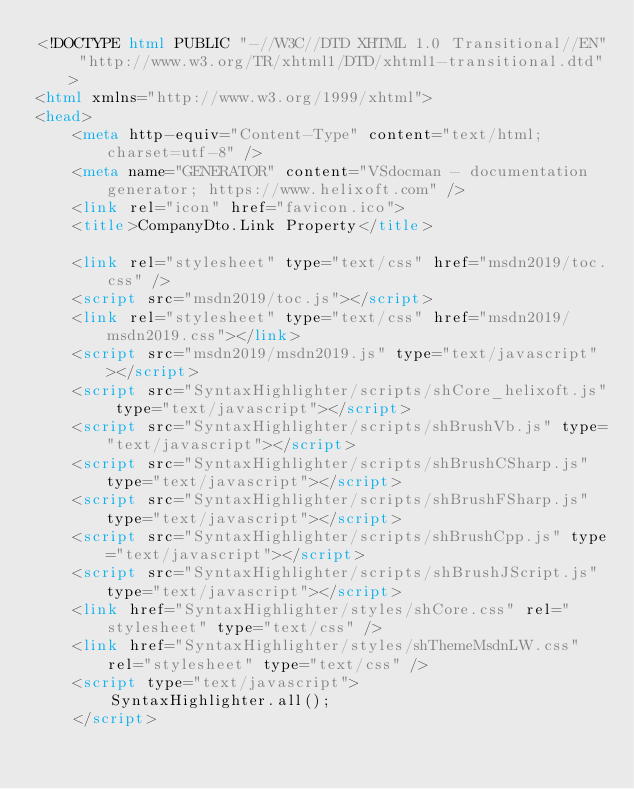<code> <loc_0><loc_0><loc_500><loc_500><_HTML_><!DOCTYPE html PUBLIC "-//W3C//DTD XHTML 1.0 Transitional//EN" "http://www.w3.org/TR/xhtml1/DTD/xhtml1-transitional.dtd">
<html xmlns="http://www.w3.org/1999/xhtml">
<head>
	<meta http-equiv="Content-Type" content="text/html; charset=utf-8" />
	<meta name="GENERATOR" content="VSdocman - documentation generator; https://www.helixoft.com" />
	<link rel="icon" href="favicon.ico">
	<title>CompanyDto.Link Property</title>

	<link rel="stylesheet" type="text/css" href="msdn2019/toc.css" />
	<script src="msdn2019/toc.js"></script>
	<link rel="stylesheet" type="text/css" href="msdn2019/msdn2019.css"></link>
	<script src="msdn2019/msdn2019.js" type="text/javascript"></script>
	<script src="SyntaxHighlighter/scripts/shCore_helixoft.js" type="text/javascript"></script>
	<script src="SyntaxHighlighter/scripts/shBrushVb.js" type="text/javascript"></script>
	<script src="SyntaxHighlighter/scripts/shBrushCSharp.js" type="text/javascript"></script>
	<script src="SyntaxHighlighter/scripts/shBrushFSharp.js" type="text/javascript"></script>
	<script src="SyntaxHighlighter/scripts/shBrushCpp.js" type="text/javascript"></script>
	<script src="SyntaxHighlighter/scripts/shBrushJScript.js" type="text/javascript"></script>
	<link href="SyntaxHighlighter/styles/shCore.css" rel="stylesheet" type="text/css" />
	<link href="SyntaxHighlighter/styles/shThemeMsdnLW.css" rel="stylesheet" type="text/css" />
	<script type="text/javascript">
		SyntaxHighlighter.all();
	</script></code> 